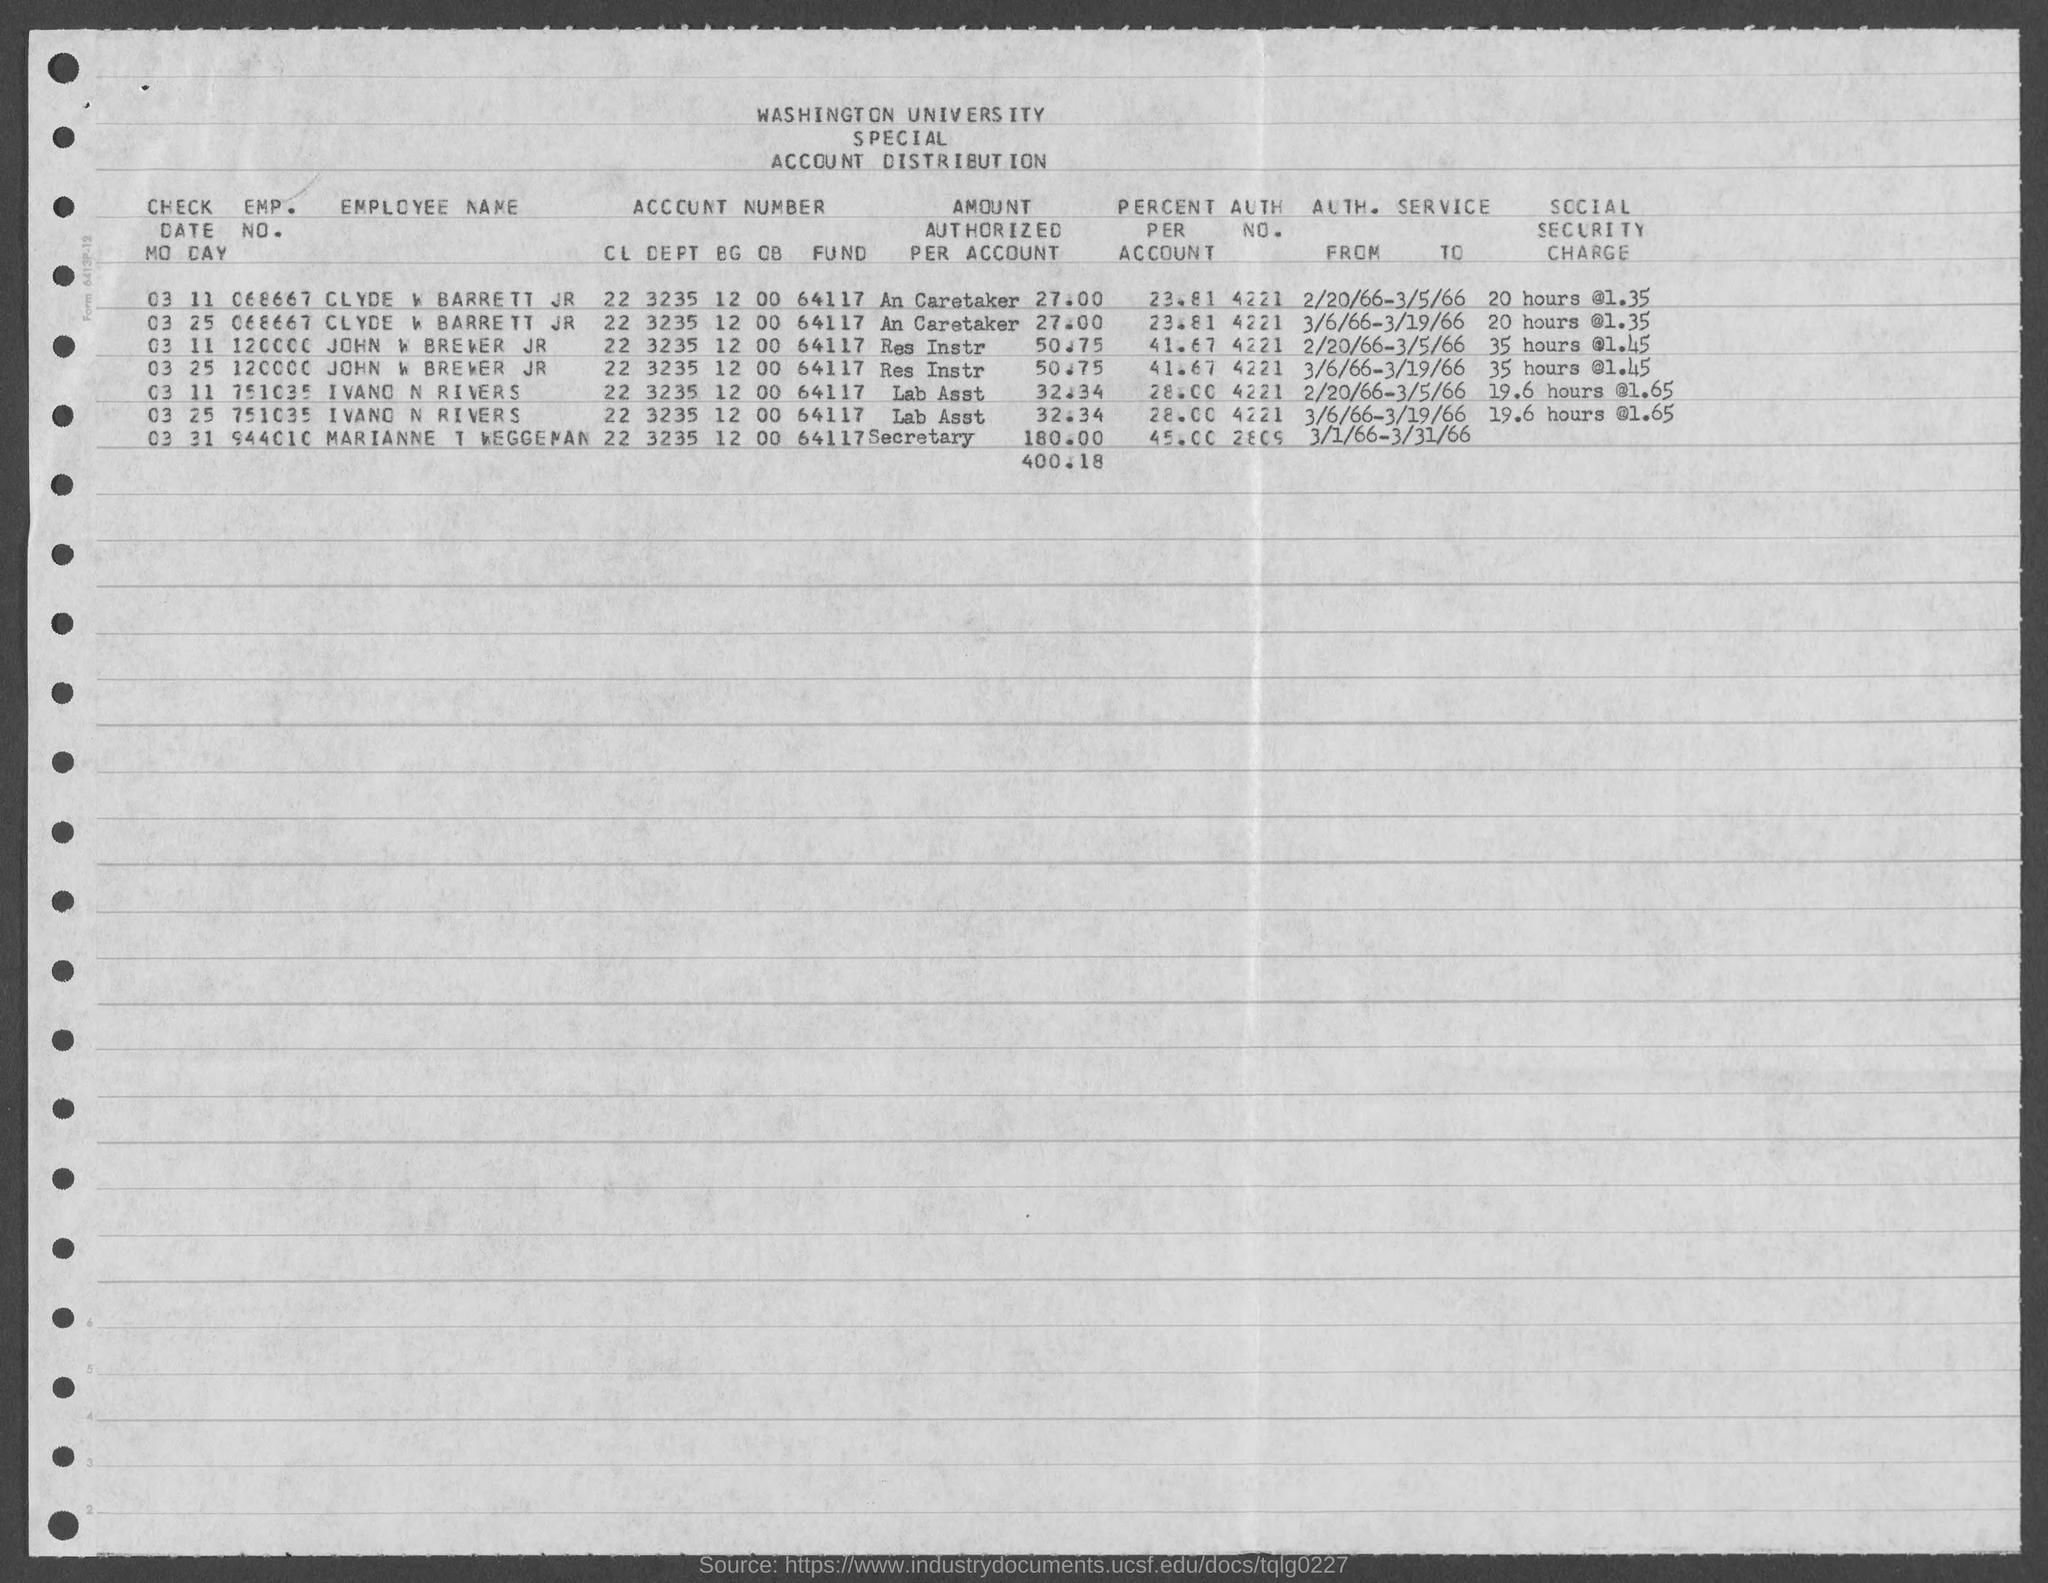What is the emp. no. of clyde w barrett jr ?
Provide a short and direct response. 068667. What is the emp. no. of  john w brewer jr ?
Provide a short and direct response. 120000. What is the emp. no. of  ivano n rivers ?
Provide a succinct answer. 751035. What is the emp. no. of  marianne t weggeman ?
Provide a short and direct response. 944010. What is the auth. no. of marianne t weggeman ?
Your answer should be very brief. 2809. What is the auth. no. of ivano n rivers?
Make the answer very short. 4221. What is the auth. no. of  john w brewer jr. ?
Your response must be concise. 4221. What is the auth. no. of clyde w barrett jr ?
Provide a short and direct response. 4221. What is the percent per person of marianne t weggeman?
Offer a terse response. 45.00. What is the percent per person of ivano n rivers ?
Give a very brief answer. 28.00. 